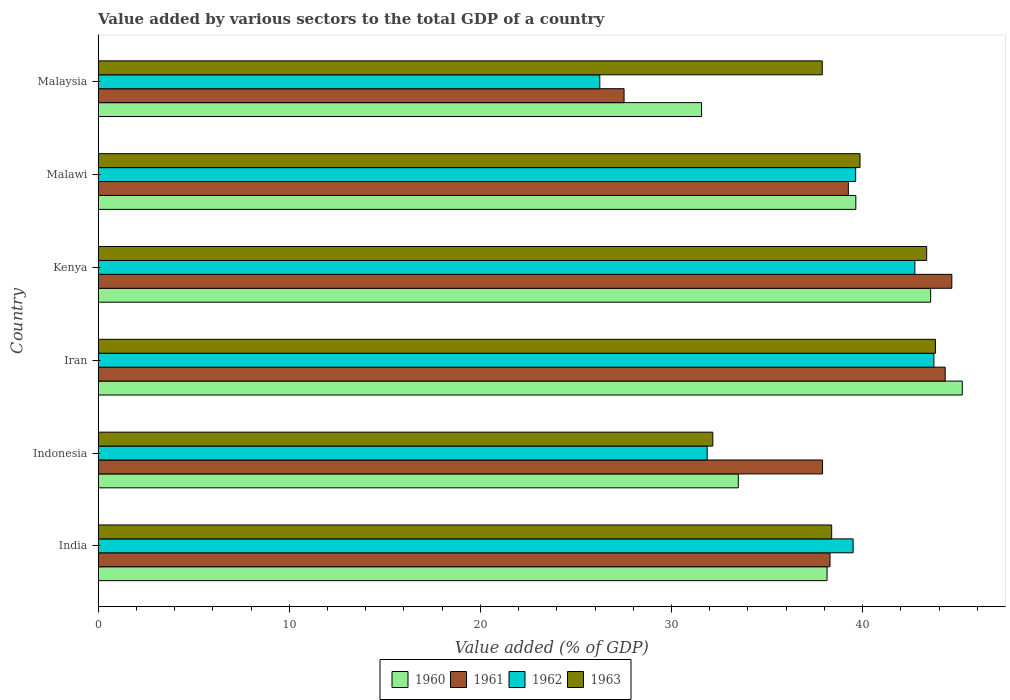How many different coloured bars are there?
Provide a succinct answer. 4. Are the number of bars per tick equal to the number of legend labels?
Your answer should be compact. Yes. Are the number of bars on each tick of the Y-axis equal?
Ensure brevity in your answer.  Yes. How many bars are there on the 4th tick from the bottom?
Offer a terse response. 4. What is the label of the 6th group of bars from the top?
Ensure brevity in your answer.  India. What is the value added by various sectors to the total GDP in 1961 in India?
Offer a very short reply. 38.29. Across all countries, what is the maximum value added by various sectors to the total GDP in 1963?
Provide a short and direct response. 43.81. Across all countries, what is the minimum value added by various sectors to the total GDP in 1963?
Ensure brevity in your answer.  32.16. In which country was the value added by various sectors to the total GDP in 1963 maximum?
Your answer should be compact. Iran. In which country was the value added by various sectors to the total GDP in 1962 minimum?
Offer a very short reply. Malaysia. What is the total value added by various sectors to the total GDP in 1962 in the graph?
Your response must be concise. 223.72. What is the difference between the value added by various sectors to the total GDP in 1962 in Indonesia and that in Kenya?
Ensure brevity in your answer.  -10.87. What is the difference between the value added by various sectors to the total GDP in 1961 in Iran and the value added by various sectors to the total GDP in 1960 in Indonesia?
Offer a very short reply. 10.82. What is the average value added by various sectors to the total GDP in 1963 per country?
Give a very brief answer. 39.24. What is the difference between the value added by various sectors to the total GDP in 1963 and value added by various sectors to the total GDP in 1962 in Indonesia?
Your answer should be very brief. 0.3. In how many countries, is the value added by various sectors to the total GDP in 1961 greater than 6 %?
Your answer should be very brief. 6. What is the ratio of the value added by various sectors to the total GDP in 1961 in India to that in Iran?
Give a very brief answer. 0.86. Is the value added by various sectors to the total GDP in 1961 in India less than that in Indonesia?
Offer a terse response. No. Is the difference between the value added by various sectors to the total GDP in 1963 in Kenya and Malawi greater than the difference between the value added by various sectors to the total GDP in 1962 in Kenya and Malawi?
Your response must be concise. Yes. What is the difference between the highest and the second highest value added by various sectors to the total GDP in 1961?
Give a very brief answer. 0.35. What is the difference between the highest and the lowest value added by various sectors to the total GDP in 1963?
Provide a succinct answer. 11.65. In how many countries, is the value added by various sectors to the total GDP in 1963 greater than the average value added by various sectors to the total GDP in 1963 taken over all countries?
Ensure brevity in your answer.  3. What does the 3rd bar from the bottom in Malaysia represents?
Give a very brief answer. 1962. Is it the case that in every country, the sum of the value added by various sectors to the total GDP in 1961 and value added by various sectors to the total GDP in 1962 is greater than the value added by various sectors to the total GDP in 1960?
Make the answer very short. Yes. How many bars are there?
Offer a terse response. 24. Are all the bars in the graph horizontal?
Provide a succinct answer. Yes. How many countries are there in the graph?
Ensure brevity in your answer.  6. Are the values on the major ticks of X-axis written in scientific E-notation?
Give a very brief answer. No. Where does the legend appear in the graph?
Provide a succinct answer. Bottom center. How are the legend labels stacked?
Give a very brief answer. Horizontal. What is the title of the graph?
Offer a terse response. Value added by various sectors to the total GDP of a country. Does "2014" appear as one of the legend labels in the graph?
Offer a terse response. No. What is the label or title of the X-axis?
Your answer should be compact. Value added (% of GDP). What is the Value added (% of GDP) in 1960 in India?
Keep it short and to the point. 38.14. What is the Value added (% of GDP) in 1961 in India?
Ensure brevity in your answer.  38.29. What is the Value added (% of GDP) in 1962 in India?
Your response must be concise. 39.5. What is the Value added (% of GDP) in 1963 in India?
Your answer should be compact. 38.38. What is the Value added (% of GDP) in 1960 in Indonesia?
Provide a succinct answer. 33.5. What is the Value added (% of GDP) of 1961 in Indonesia?
Offer a terse response. 37.9. What is the Value added (% of GDP) of 1962 in Indonesia?
Ensure brevity in your answer.  31.87. What is the Value added (% of GDP) in 1963 in Indonesia?
Provide a succinct answer. 32.16. What is the Value added (% of GDP) in 1960 in Iran?
Your answer should be compact. 45.21. What is the Value added (% of GDP) in 1961 in Iran?
Provide a short and direct response. 44.32. What is the Value added (% of GDP) in 1962 in Iran?
Offer a very short reply. 43.73. What is the Value added (% of GDP) of 1963 in Iran?
Offer a very short reply. 43.81. What is the Value added (% of GDP) in 1960 in Kenya?
Keep it short and to the point. 43.56. What is the Value added (% of GDP) of 1961 in Kenya?
Keep it short and to the point. 44.67. What is the Value added (% of GDP) in 1962 in Kenya?
Your answer should be compact. 42.73. What is the Value added (% of GDP) of 1963 in Kenya?
Make the answer very short. 43.35. What is the Value added (% of GDP) in 1960 in Malawi?
Give a very brief answer. 39.64. What is the Value added (% of GDP) of 1961 in Malawi?
Keep it short and to the point. 39.25. What is the Value added (% of GDP) in 1962 in Malawi?
Your answer should be very brief. 39.64. What is the Value added (% of GDP) of 1963 in Malawi?
Offer a terse response. 39.86. What is the Value added (% of GDP) of 1960 in Malaysia?
Offer a terse response. 31.57. What is the Value added (% of GDP) of 1961 in Malaysia?
Keep it short and to the point. 27.52. What is the Value added (% of GDP) in 1962 in Malaysia?
Make the answer very short. 26.25. What is the Value added (% of GDP) of 1963 in Malaysia?
Keep it short and to the point. 37.89. Across all countries, what is the maximum Value added (% of GDP) of 1960?
Your answer should be very brief. 45.21. Across all countries, what is the maximum Value added (% of GDP) in 1961?
Your answer should be very brief. 44.67. Across all countries, what is the maximum Value added (% of GDP) in 1962?
Give a very brief answer. 43.73. Across all countries, what is the maximum Value added (% of GDP) in 1963?
Give a very brief answer. 43.81. Across all countries, what is the minimum Value added (% of GDP) of 1960?
Ensure brevity in your answer.  31.57. Across all countries, what is the minimum Value added (% of GDP) in 1961?
Keep it short and to the point. 27.52. Across all countries, what is the minimum Value added (% of GDP) in 1962?
Give a very brief answer. 26.25. Across all countries, what is the minimum Value added (% of GDP) in 1963?
Provide a succinct answer. 32.16. What is the total Value added (% of GDP) in 1960 in the graph?
Your answer should be very brief. 231.63. What is the total Value added (% of GDP) in 1961 in the graph?
Make the answer very short. 231.95. What is the total Value added (% of GDP) in 1962 in the graph?
Your answer should be very brief. 223.72. What is the total Value added (% of GDP) of 1963 in the graph?
Keep it short and to the point. 235.46. What is the difference between the Value added (% of GDP) of 1960 in India and that in Indonesia?
Your response must be concise. 4.64. What is the difference between the Value added (% of GDP) of 1961 in India and that in Indonesia?
Your answer should be compact. 0.39. What is the difference between the Value added (% of GDP) of 1962 in India and that in Indonesia?
Offer a terse response. 7.64. What is the difference between the Value added (% of GDP) in 1963 in India and that in Indonesia?
Your response must be concise. 6.22. What is the difference between the Value added (% of GDP) of 1960 in India and that in Iran?
Keep it short and to the point. -7.08. What is the difference between the Value added (% of GDP) of 1961 in India and that in Iran?
Keep it short and to the point. -6.03. What is the difference between the Value added (% of GDP) of 1962 in India and that in Iran?
Your answer should be compact. -4.23. What is the difference between the Value added (% of GDP) of 1963 in India and that in Iran?
Ensure brevity in your answer.  -5.43. What is the difference between the Value added (% of GDP) in 1960 in India and that in Kenya?
Ensure brevity in your answer.  -5.42. What is the difference between the Value added (% of GDP) in 1961 in India and that in Kenya?
Offer a very short reply. -6.37. What is the difference between the Value added (% of GDP) of 1962 in India and that in Kenya?
Your answer should be compact. -3.23. What is the difference between the Value added (% of GDP) of 1963 in India and that in Kenya?
Provide a succinct answer. -4.97. What is the difference between the Value added (% of GDP) in 1960 in India and that in Malawi?
Provide a short and direct response. -1.51. What is the difference between the Value added (% of GDP) of 1961 in India and that in Malawi?
Give a very brief answer. -0.96. What is the difference between the Value added (% of GDP) of 1962 in India and that in Malawi?
Offer a very short reply. -0.13. What is the difference between the Value added (% of GDP) of 1963 in India and that in Malawi?
Your answer should be compact. -1.48. What is the difference between the Value added (% of GDP) in 1960 in India and that in Malaysia?
Ensure brevity in your answer.  6.57. What is the difference between the Value added (% of GDP) of 1961 in India and that in Malaysia?
Your response must be concise. 10.77. What is the difference between the Value added (% of GDP) of 1962 in India and that in Malaysia?
Ensure brevity in your answer.  13.25. What is the difference between the Value added (% of GDP) of 1963 in India and that in Malaysia?
Ensure brevity in your answer.  0.49. What is the difference between the Value added (% of GDP) of 1960 in Indonesia and that in Iran?
Your response must be concise. -11.72. What is the difference between the Value added (% of GDP) in 1961 in Indonesia and that in Iran?
Your answer should be compact. -6.42. What is the difference between the Value added (% of GDP) in 1962 in Indonesia and that in Iran?
Your answer should be very brief. -11.86. What is the difference between the Value added (% of GDP) of 1963 in Indonesia and that in Iran?
Your response must be concise. -11.65. What is the difference between the Value added (% of GDP) of 1960 in Indonesia and that in Kenya?
Ensure brevity in your answer.  -10.06. What is the difference between the Value added (% of GDP) of 1961 in Indonesia and that in Kenya?
Ensure brevity in your answer.  -6.76. What is the difference between the Value added (% of GDP) of 1962 in Indonesia and that in Kenya?
Make the answer very short. -10.87. What is the difference between the Value added (% of GDP) in 1963 in Indonesia and that in Kenya?
Ensure brevity in your answer.  -11.19. What is the difference between the Value added (% of GDP) in 1960 in Indonesia and that in Malawi?
Provide a succinct answer. -6.15. What is the difference between the Value added (% of GDP) of 1961 in Indonesia and that in Malawi?
Ensure brevity in your answer.  -1.35. What is the difference between the Value added (% of GDP) of 1962 in Indonesia and that in Malawi?
Your answer should be compact. -7.77. What is the difference between the Value added (% of GDP) of 1963 in Indonesia and that in Malawi?
Offer a terse response. -7.7. What is the difference between the Value added (% of GDP) in 1960 in Indonesia and that in Malaysia?
Provide a short and direct response. 1.92. What is the difference between the Value added (% of GDP) in 1961 in Indonesia and that in Malaysia?
Offer a very short reply. 10.39. What is the difference between the Value added (% of GDP) of 1962 in Indonesia and that in Malaysia?
Provide a short and direct response. 5.62. What is the difference between the Value added (% of GDP) of 1963 in Indonesia and that in Malaysia?
Keep it short and to the point. -5.73. What is the difference between the Value added (% of GDP) of 1960 in Iran and that in Kenya?
Your answer should be very brief. 1.65. What is the difference between the Value added (% of GDP) in 1961 in Iran and that in Kenya?
Ensure brevity in your answer.  -0.35. What is the difference between the Value added (% of GDP) of 1963 in Iran and that in Kenya?
Offer a very short reply. 0.46. What is the difference between the Value added (% of GDP) in 1960 in Iran and that in Malawi?
Your answer should be very brief. 5.57. What is the difference between the Value added (% of GDP) of 1961 in Iran and that in Malawi?
Keep it short and to the point. 5.07. What is the difference between the Value added (% of GDP) of 1962 in Iran and that in Malawi?
Make the answer very short. 4.09. What is the difference between the Value added (% of GDP) in 1963 in Iran and that in Malawi?
Your answer should be compact. 3.95. What is the difference between the Value added (% of GDP) in 1960 in Iran and that in Malaysia?
Provide a succinct answer. 13.64. What is the difference between the Value added (% of GDP) in 1961 in Iran and that in Malaysia?
Keep it short and to the point. 16.8. What is the difference between the Value added (% of GDP) in 1962 in Iran and that in Malaysia?
Offer a very short reply. 17.48. What is the difference between the Value added (% of GDP) in 1963 in Iran and that in Malaysia?
Offer a very short reply. 5.92. What is the difference between the Value added (% of GDP) of 1960 in Kenya and that in Malawi?
Keep it short and to the point. 3.92. What is the difference between the Value added (% of GDP) in 1961 in Kenya and that in Malawi?
Make the answer very short. 5.41. What is the difference between the Value added (% of GDP) of 1962 in Kenya and that in Malawi?
Make the answer very short. 3.1. What is the difference between the Value added (% of GDP) in 1963 in Kenya and that in Malawi?
Your answer should be compact. 3.49. What is the difference between the Value added (% of GDP) in 1960 in Kenya and that in Malaysia?
Your response must be concise. 11.99. What is the difference between the Value added (% of GDP) in 1961 in Kenya and that in Malaysia?
Offer a very short reply. 17.15. What is the difference between the Value added (% of GDP) in 1962 in Kenya and that in Malaysia?
Your answer should be compact. 16.48. What is the difference between the Value added (% of GDP) of 1963 in Kenya and that in Malaysia?
Ensure brevity in your answer.  5.46. What is the difference between the Value added (% of GDP) of 1960 in Malawi and that in Malaysia?
Make the answer very short. 8.07. What is the difference between the Value added (% of GDP) of 1961 in Malawi and that in Malaysia?
Your answer should be very brief. 11.73. What is the difference between the Value added (% of GDP) of 1962 in Malawi and that in Malaysia?
Ensure brevity in your answer.  13.39. What is the difference between the Value added (% of GDP) of 1963 in Malawi and that in Malaysia?
Offer a very short reply. 1.98. What is the difference between the Value added (% of GDP) in 1960 in India and the Value added (% of GDP) in 1961 in Indonesia?
Your answer should be compact. 0.24. What is the difference between the Value added (% of GDP) of 1960 in India and the Value added (% of GDP) of 1962 in Indonesia?
Ensure brevity in your answer.  6.27. What is the difference between the Value added (% of GDP) of 1960 in India and the Value added (% of GDP) of 1963 in Indonesia?
Offer a terse response. 5.98. What is the difference between the Value added (% of GDP) in 1961 in India and the Value added (% of GDP) in 1962 in Indonesia?
Provide a succinct answer. 6.43. What is the difference between the Value added (% of GDP) in 1961 in India and the Value added (% of GDP) in 1963 in Indonesia?
Ensure brevity in your answer.  6.13. What is the difference between the Value added (% of GDP) in 1962 in India and the Value added (% of GDP) in 1963 in Indonesia?
Offer a very short reply. 7.34. What is the difference between the Value added (% of GDP) in 1960 in India and the Value added (% of GDP) in 1961 in Iran?
Ensure brevity in your answer.  -6.18. What is the difference between the Value added (% of GDP) of 1960 in India and the Value added (% of GDP) of 1962 in Iran?
Provide a succinct answer. -5.59. What is the difference between the Value added (% of GDP) of 1960 in India and the Value added (% of GDP) of 1963 in Iran?
Offer a very short reply. -5.67. What is the difference between the Value added (% of GDP) in 1961 in India and the Value added (% of GDP) in 1962 in Iran?
Your response must be concise. -5.44. What is the difference between the Value added (% of GDP) in 1961 in India and the Value added (% of GDP) in 1963 in Iran?
Offer a terse response. -5.52. What is the difference between the Value added (% of GDP) in 1962 in India and the Value added (% of GDP) in 1963 in Iran?
Keep it short and to the point. -4.31. What is the difference between the Value added (% of GDP) in 1960 in India and the Value added (% of GDP) in 1961 in Kenya?
Your response must be concise. -6.53. What is the difference between the Value added (% of GDP) in 1960 in India and the Value added (% of GDP) in 1962 in Kenya?
Your answer should be very brief. -4.59. What is the difference between the Value added (% of GDP) of 1960 in India and the Value added (% of GDP) of 1963 in Kenya?
Your answer should be very brief. -5.21. What is the difference between the Value added (% of GDP) in 1961 in India and the Value added (% of GDP) in 1962 in Kenya?
Provide a short and direct response. -4.44. What is the difference between the Value added (% of GDP) of 1961 in India and the Value added (% of GDP) of 1963 in Kenya?
Provide a short and direct response. -5.06. What is the difference between the Value added (% of GDP) in 1962 in India and the Value added (% of GDP) in 1963 in Kenya?
Keep it short and to the point. -3.85. What is the difference between the Value added (% of GDP) of 1960 in India and the Value added (% of GDP) of 1961 in Malawi?
Provide a succinct answer. -1.11. What is the difference between the Value added (% of GDP) in 1960 in India and the Value added (% of GDP) in 1962 in Malawi?
Offer a terse response. -1.5. What is the difference between the Value added (% of GDP) in 1960 in India and the Value added (% of GDP) in 1963 in Malawi?
Your response must be concise. -1.72. What is the difference between the Value added (% of GDP) in 1961 in India and the Value added (% of GDP) in 1962 in Malawi?
Make the answer very short. -1.34. What is the difference between the Value added (% of GDP) in 1961 in India and the Value added (% of GDP) in 1963 in Malawi?
Your answer should be compact. -1.57. What is the difference between the Value added (% of GDP) of 1962 in India and the Value added (% of GDP) of 1963 in Malawi?
Offer a very short reply. -0.36. What is the difference between the Value added (% of GDP) of 1960 in India and the Value added (% of GDP) of 1961 in Malaysia?
Offer a terse response. 10.62. What is the difference between the Value added (% of GDP) of 1960 in India and the Value added (% of GDP) of 1962 in Malaysia?
Provide a succinct answer. 11.89. What is the difference between the Value added (% of GDP) in 1960 in India and the Value added (% of GDP) in 1963 in Malaysia?
Provide a short and direct response. 0.25. What is the difference between the Value added (% of GDP) in 1961 in India and the Value added (% of GDP) in 1962 in Malaysia?
Offer a terse response. 12.04. What is the difference between the Value added (% of GDP) in 1961 in India and the Value added (% of GDP) in 1963 in Malaysia?
Your answer should be very brief. 0.41. What is the difference between the Value added (% of GDP) of 1962 in India and the Value added (% of GDP) of 1963 in Malaysia?
Provide a short and direct response. 1.62. What is the difference between the Value added (% of GDP) of 1960 in Indonesia and the Value added (% of GDP) of 1961 in Iran?
Offer a very short reply. -10.82. What is the difference between the Value added (% of GDP) of 1960 in Indonesia and the Value added (% of GDP) of 1962 in Iran?
Offer a very short reply. -10.24. What is the difference between the Value added (% of GDP) in 1960 in Indonesia and the Value added (% of GDP) in 1963 in Iran?
Your answer should be very brief. -10.32. What is the difference between the Value added (% of GDP) of 1961 in Indonesia and the Value added (% of GDP) of 1962 in Iran?
Provide a succinct answer. -5.83. What is the difference between the Value added (% of GDP) of 1961 in Indonesia and the Value added (% of GDP) of 1963 in Iran?
Provide a succinct answer. -5.91. What is the difference between the Value added (% of GDP) of 1962 in Indonesia and the Value added (% of GDP) of 1963 in Iran?
Ensure brevity in your answer.  -11.94. What is the difference between the Value added (% of GDP) in 1960 in Indonesia and the Value added (% of GDP) in 1961 in Kenya?
Provide a short and direct response. -11.17. What is the difference between the Value added (% of GDP) of 1960 in Indonesia and the Value added (% of GDP) of 1962 in Kenya?
Keep it short and to the point. -9.24. What is the difference between the Value added (% of GDP) in 1960 in Indonesia and the Value added (% of GDP) in 1963 in Kenya?
Your response must be concise. -9.86. What is the difference between the Value added (% of GDP) in 1961 in Indonesia and the Value added (% of GDP) in 1962 in Kenya?
Offer a very short reply. -4.83. What is the difference between the Value added (% of GDP) of 1961 in Indonesia and the Value added (% of GDP) of 1963 in Kenya?
Offer a very short reply. -5.45. What is the difference between the Value added (% of GDP) in 1962 in Indonesia and the Value added (% of GDP) in 1963 in Kenya?
Give a very brief answer. -11.48. What is the difference between the Value added (% of GDP) in 1960 in Indonesia and the Value added (% of GDP) in 1961 in Malawi?
Keep it short and to the point. -5.76. What is the difference between the Value added (% of GDP) in 1960 in Indonesia and the Value added (% of GDP) in 1962 in Malawi?
Offer a very short reply. -6.14. What is the difference between the Value added (% of GDP) of 1960 in Indonesia and the Value added (% of GDP) of 1963 in Malawi?
Your answer should be compact. -6.37. What is the difference between the Value added (% of GDP) of 1961 in Indonesia and the Value added (% of GDP) of 1962 in Malawi?
Offer a very short reply. -1.73. What is the difference between the Value added (% of GDP) of 1961 in Indonesia and the Value added (% of GDP) of 1963 in Malawi?
Provide a succinct answer. -1.96. What is the difference between the Value added (% of GDP) in 1962 in Indonesia and the Value added (% of GDP) in 1963 in Malawi?
Your answer should be very brief. -8. What is the difference between the Value added (% of GDP) of 1960 in Indonesia and the Value added (% of GDP) of 1961 in Malaysia?
Provide a succinct answer. 5.98. What is the difference between the Value added (% of GDP) in 1960 in Indonesia and the Value added (% of GDP) in 1962 in Malaysia?
Offer a very short reply. 7.25. What is the difference between the Value added (% of GDP) in 1960 in Indonesia and the Value added (% of GDP) in 1963 in Malaysia?
Make the answer very short. -4.39. What is the difference between the Value added (% of GDP) in 1961 in Indonesia and the Value added (% of GDP) in 1962 in Malaysia?
Offer a very short reply. 11.65. What is the difference between the Value added (% of GDP) of 1961 in Indonesia and the Value added (% of GDP) of 1963 in Malaysia?
Your response must be concise. 0.02. What is the difference between the Value added (% of GDP) in 1962 in Indonesia and the Value added (% of GDP) in 1963 in Malaysia?
Give a very brief answer. -6.02. What is the difference between the Value added (% of GDP) of 1960 in Iran and the Value added (% of GDP) of 1961 in Kenya?
Provide a short and direct response. 0.55. What is the difference between the Value added (% of GDP) of 1960 in Iran and the Value added (% of GDP) of 1962 in Kenya?
Your response must be concise. 2.48. What is the difference between the Value added (% of GDP) in 1960 in Iran and the Value added (% of GDP) in 1963 in Kenya?
Provide a short and direct response. 1.86. What is the difference between the Value added (% of GDP) in 1961 in Iran and the Value added (% of GDP) in 1962 in Kenya?
Your answer should be very brief. 1.59. What is the difference between the Value added (% of GDP) in 1961 in Iran and the Value added (% of GDP) in 1963 in Kenya?
Make the answer very short. 0.97. What is the difference between the Value added (% of GDP) in 1962 in Iran and the Value added (% of GDP) in 1963 in Kenya?
Your answer should be compact. 0.38. What is the difference between the Value added (% of GDP) of 1960 in Iran and the Value added (% of GDP) of 1961 in Malawi?
Offer a terse response. 5.96. What is the difference between the Value added (% of GDP) of 1960 in Iran and the Value added (% of GDP) of 1962 in Malawi?
Provide a short and direct response. 5.58. What is the difference between the Value added (% of GDP) of 1960 in Iran and the Value added (% of GDP) of 1963 in Malawi?
Your answer should be very brief. 5.35. What is the difference between the Value added (% of GDP) of 1961 in Iran and the Value added (% of GDP) of 1962 in Malawi?
Provide a short and direct response. 4.68. What is the difference between the Value added (% of GDP) in 1961 in Iran and the Value added (% of GDP) in 1963 in Malawi?
Ensure brevity in your answer.  4.46. What is the difference between the Value added (% of GDP) of 1962 in Iran and the Value added (% of GDP) of 1963 in Malawi?
Ensure brevity in your answer.  3.87. What is the difference between the Value added (% of GDP) of 1960 in Iran and the Value added (% of GDP) of 1961 in Malaysia?
Give a very brief answer. 17.7. What is the difference between the Value added (% of GDP) of 1960 in Iran and the Value added (% of GDP) of 1962 in Malaysia?
Provide a succinct answer. 18.96. What is the difference between the Value added (% of GDP) in 1960 in Iran and the Value added (% of GDP) in 1963 in Malaysia?
Provide a succinct answer. 7.33. What is the difference between the Value added (% of GDP) in 1961 in Iran and the Value added (% of GDP) in 1962 in Malaysia?
Give a very brief answer. 18.07. What is the difference between the Value added (% of GDP) in 1961 in Iran and the Value added (% of GDP) in 1963 in Malaysia?
Make the answer very short. 6.43. What is the difference between the Value added (% of GDP) in 1962 in Iran and the Value added (% of GDP) in 1963 in Malaysia?
Make the answer very short. 5.84. What is the difference between the Value added (% of GDP) in 1960 in Kenya and the Value added (% of GDP) in 1961 in Malawi?
Offer a terse response. 4.31. What is the difference between the Value added (% of GDP) of 1960 in Kenya and the Value added (% of GDP) of 1962 in Malawi?
Ensure brevity in your answer.  3.92. What is the difference between the Value added (% of GDP) in 1960 in Kenya and the Value added (% of GDP) in 1963 in Malawi?
Ensure brevity in your answer.  3.7. What is the difference between the Value added (% of GDP) of 1961 in Kenya and the Value added (% of GDP) of 1962 in Malawi?
Your answer should be very brief. 5.03. What is the difference between the Value added (% of GDP) of 1961 in Kenya and the Value added (% of GDP) of 1963 in Malawi?
Offer a very short reply. 4.8. What is the difference between the Value added (% of GDP) of 1962 in Kenya and the Value added (% of GDP) of 1963 in Malawi?
Keep it short and to the point. 2.87. What is the difference between the Value added (% of GDP) in 1960 in Kenya and the Value added (% of GDP) in 1961 in Malaysia?
Offer a very short reply. 16.04. What is the difference between the Value added (% of GDP) of 1960 in Kenya and the Value added (% of GDP) of 1962 in Malaysia?
Provide a succinct answer. 17.31. What is the difference between the Value added (% of GDP) of 1960 in Kenya and the Value added (% of GDP) of 1963 in Malaysia?
Your answer should be compact. 5.67. What is the difference between the Value added (% of GDP) in 1961 in Kenya and the Value added (% of GDP) in 1962 in Malaysia?
Ensure brevity in your answer.  18.42. What is the difference between the Value added (% of GDP) of 1961 in Kenya and the Value added (% of GDP) of 1963 in Malaysia?
Keep it short and to the point. 6.78. What is the difference between the Value added (% of GDP) in 1962 in Kenya and the Value added (% of GDP) in 1963 in Malaysia?
Ensure brevity in your answer.  4.84. What is the difference between the Value added (% of GDP) of 1960 in Malawi and the Value added (% of GDP) of 1961 in Malaysia?
Offer a very short reply. 12.13. What is the difference between the Value added (% of GDP) of 1960 in Malawi and the Value added (% of GDP) of 1962 in Malaysia?
Provide a succinct answer. 13.39. What is the difference between the Value added (% of GDP) of 1960 in Malawi and the Value added (% of GDP) of 1963 in Malaysia?
Offer a terse response. 1.76. What is the difference between the Value added (% of GDP) in 1961 in Malawi and the Value added (% of GDP) in 1962 in Malaysia?
Offer a terse response. 13. What is the difference between the Value added (% of GDP) in 1961 in Malawi and the Value added (% of GDP) in 1963 in Malaysia?
Ensure brevity in your answer.  1.37. What is the difference between the Value added (% of GDP) in 1962 in Malawi and the Value added (% of GDP) in 1963 in Malaysia?
Ensure brevity in your answer.  1.75. What is the average Value added (% of GDP) in 1960 per country?
Make the answer very short. 38.6. What is the average Value added (% of GDP) in 1961 per country?
Give a very brief answer. 38.66. What is the average Value added (% of GDP) in 1962 per country?
Make the answer very short. 37.29. What is the average Value added (% of GDP) in 1963 per country?
Make the answer very short. 39.24. What is the difference between the Value added (% of GDP) in 1960 and Value added (% of GDP) in 1961 in India?
Provide a short and direct response. -0.15. What is the difference between the Value added (% of GDP) in 1960 and Value added (% of GDP) in 1962 in India?
Offer a terse response. -1.36. What is the difference between the Value added (% of GDP) of 1960 and Value added (% of GDP) of 1963 in India?
Make the answer very short. -0.24. What is the difference between the Value added (% of GDP) of 1961 and Value added (% of GDP) of 1962 in India?
Make the answer very short. -1.21. What is the difference between the Value added (% of GDP) in 1961 and Value added (% of GDP) in 1963 in India?
Offer a very short reply. -0.09. What is the difference between the Value added (% of GDP) of 1962 and Value added (% of GDP) of 1963 in India?
Provide a short and direct response. 1.12. What is the difference between the Value added (% of GDP) in 1960 and Value added (% of GDP) in 1961 in Indonesia?
Your response must be concise. -4.41. What is the difference between the Value added (% of GDP) of 1960 and Value added (% of GDP) of 1962 in Indonesia?
Give a very brief answer. 1.63. What is the difference between the Value added (% of GDP) in 1960 and Value added (% of GDP) in 1963 in Indonesia?
Make the answer very short. 1.33. What is the difference between the Value added (% of GDP) in 1961 and Value added (% of GDP) in 1962 in Indonesia?
Offer a very short reply. 6.04. What is the difference between the Value added (% of GDP) in 1961 and Value added (% of GDP) in 1963 in Indonesia?
Give a very brief answer. 5.74. What is the difference between the Value added (% of GDP) in 1962 and Value added (% of GDP) in 1963 in Indonesia?
Keep it short and to the point. -0.3. What is the difference between the Value added (% of GDP) of 1960 and Value added (% of GDP) of 1961 in Iran?
Your answer should be compact. 0.89. What is the difference between the Value added (% of GDP) in 1960 and Value added (% of GDP) in 1962 in Iran?
Give a very brief answer. 1.48. What is the difference between the Value added (% of GDP) in 1960 and Value added (% of GDP) in 1963 in Iran?
Your answer should be compact. 1.4. What is the difference between the Value added (% of GDP) in 1961 and Value added (% of GDP) in 1962 in Iran?
Offer a terse response. 0.59. What is the difference between the Value added (% of GDP) of 1961 and Value added (% of GDP) of 1963 in Iran?
Make the answer very short. 0.51. What is the difference between the Value added (% of GDP) in 1962 and Value added (% of GDP) in 1963 in Iran?
Offer a very short reply. -0.08. What is the difference between the Value added (% of GDP) of 1960 and Value added (% of GDP) of 1961 in Kenya?
Make the answer very short. -1.11. What is the difference between the Value added (% of GDP) of 1960 and Value added (% of GDP) of 1962 in Kenya?
Your answer should be very brief. 0.83. What is the difference between the Value added (% of GDP) in 1960 and Value added (% of GDP) in 1963 in Kenya?
Your response must be concise. 0.21. What is the difference between the Value added (% of GDP) of 1961 and Value added (% of GDP) of 1962 in Kenya?
Offer a very short reply. 1.94. What is the difference between the Value added (% of GDP) of 1961 and Value added (% of GDP) of 1963 in Kenya?
Provide a succinct answer. 1.32. What is the difference between the Value added (% of GDP) of 1962 and Value added (% of GDP) of 1963 in Kenya?
Ensure brevity in your answer.  -0.62. What is the difference between the Value added (% of GDP) of 1960 and Value added (% of GDP) of 1961 in Malawi?
Ensure brevity in your answer.  0.39. What is the difference between the Value added (% of GDP) in 1960 and Value added (% of GDP) in 1962 in Malawi?
Make the answer very short. 0.01. What is the difference between the Value added (% of GDP) of 1960 and Value added (% of GDP) of 1963 in Malawi?
Your answer should be very brief. -0.22. What is the difference between the Value added (% of GDP) in 1961 and Value added (% of GDP) in 1962 in Malawi?
Make the answer very short. -0.38. What is the difference between the Value added (% of GDP) of 1961 and Value added (% of GDP) of 1963 in Malawi?
Provide a short and direct response. -0.61. What is the difference between the Value added (% of GDP) of 1962 and Value added (% of GDP) of 1963 in Malawi?
Give a very brief answer. -0.23. What is the difference between the Value added (% of GDP) in 1960 and Value added (% of GDP) in 1961 in Malaysia?
Your answer should be very brief. 4.05. What is the difference between the Value added (% of GDP) of 1960 and Value added (% of GDP) of 1962 in Malaysia?
Your answer should be very brief. 5.32. What is the difference between the Value added (% of GDP) in 1960 and Value added (% of GDP) in 1963 in Malaysia?
Ensure brevity in your answer.  -6.31. What is the difference between the Value added (% of GDP) of 1961 and Value added (% of GDP) of 1962 in Malaysia?
Offer a very short reply. 1.27. What is the difference between the Value added (% of GDP) of 1961 and Value added (% of GDP) of 1963 in Malaysia?
Make the answer very short. -10.37. What is the difference between the Value added (% of GDP) in 1962 and Value added (% of GDP) in 1963 in Malaysia?
Provide a short and direct response. -11.64. What is the ratio of the Value added (% of GDP) of 1960 in India to that in Indonesia?
Ensure brevity in your answer.  1.14. What is the ratio of the Value added (% of GDP) of 1961 in India to that in Indonesia?
Provide a succinct answer. 1.01. What is the ratio of the Value added (% of GDP) in 1962 in India to that in Indonesia?
Your answer should be compact. 1.24. What is the ratio of the Value added (% of GDP) in 1963 in India to that in Indonesia?
Provide a short and direct response. 1.19. What is the ratio of the Value added (% of GDP) in 1960 in India to that in Iran?
Provide a succinct answer. 0.84. What is the ratio of the Value added (% of GDP) of 1961 in India to that in Iran?
Provide a succinct answer. 0.86. What is the ratio of the Value added (% of GDP) of 1962 in India to that in Iran?
Provide a short and direct response. 0.9. What is the ratio of the Value added (% of GDP) in 1963 in India to that in Iran?
Provide a succinct answer. 0.88. What is the ratio of the Value added (% of GDP) in 1960 in India to that in Kenya?
Your answer should be compact. 0.88. What is the ratio of the Value added (% of GDP) in 1961 in India to that in Kenya?
Your answer should be very brief. 0.86. What is the ratio of the Value added (% of GDP) in 1962 in India to that in Kenya?
Provide a succinct answer. 0.92. What is the ratio of the Value added (% of GDP) in 1963 in India to that in Kenya?
Your answer should be compact. 0.89. What is the ratio of the Value added (% of GDP) in 1960 in India to that in Malawi?
Give a very brief answer. 0.96. What is the ratio of the Value added (% of GDP) in 1961 in India to that in Malawi?
Your response must be concise. 0.98. What is the ratio of the Value added (% of GDP) of 1962 in India to that in Malawi?
Provide a succinct answer. 1. What is the ratio of the Value added (% of GDP) of 1963 in India to that in Malawi?
Your response must be concise. 0.96. What is the ratio of the Value added (% of GDP) in 1960 in India to that in Malaysia?
Keep it short and to the point. 1.21. What is the ratio of the Value added (% of GDP) of 1961 in India to that in Malaysia?
Keep it short and to the point. 1.39. What is the ratio of the Value added (% of GDP) of 1962 in India to that in Malaysia?
Your answer should be compact. 1.5. What is the ratio of the Value added (% of GDP) of 1963 in India to that in Malaysia?
Ensure brevity in your answer.  1.01. What is the ratio of the Value added (% of GDP) of 1960 in Indonesia to that in Iran?
Provide a short and direct response. 0.74. What is the ratio of the Value added (% of GDP) in 1961 in Indonesia to that in Iran?
Give a very brief answer. 0.86. What is the ratio of the Value added (% of GDP) of 1962 in Indonesia to that in Iran?
Offer a very short reply. 0.73. What is the ratio of the Value added (% of GDP) of 1963 in Indonesia to that in Iran?
Provide a succinct answer. 0.73. What is the ratio of the Value added (% of GDP) in 1960 in Indonesia to that in Kenya?
Keep it short and to the point. 0.77. What is the ratio of the Value added (% of GDP) of 1961 in Indonesia to that in Kenya?
Give a very brief answer. 0.85. What is the ratio of the Value added (% of GDP) in 1962 in Indonesia to that in Kenya?
Provide a short and direct response. 0.75. What is the ratio of the Value added (% of GDP) of 1963 in Indonesia to that in Kenya?
Your response must be concise. 0.74. What is the ratio of the Value added (% of GDP) in 1960 in Indonesia to that in Malawi?
Offer a terse response. 0.84. What is the ratio of the Value added (% of GDP) in 1961 in Indonesia to that in Malawi?
Your answer should be compact. 0.97. What is the ratio of the Value added (% of GDP) of 1962 in Indonesia to that in Malawi?
Keep it short and to the point. 0.8. What is the ratio of the Value added (% of GDP) in 1963 in Indonesia to that in Malawi?
Provide a succinct answer. 0.81. What is the ratio of the Value added (% of GDP) of 1960 in Indonesia to that in Malaysia?
Ensure brevity in your answer.  1.06. What is the ratio of the Value added (% of GDP) in 1961 in Indonesia to that in Malaysia?
Make the answer very short. 1.38. What is the ratio of the Value added (% of GDP) in 1962 in Indonesia to that in Malaysia?
Keep it short and to the point. 1.21. What is the ratio of the Value added (% of GDP) in 1963 in Indonesia to that in Malaysia?
Ensure brevity in your answer.  0.85. What is the ratio of the Value added (% of GDP) of 1960 in Iran to that in Kenya?
Offer a terse response. 1.04. What is the ratio of the Value added (% of GDP) in 1962 in Iran to that in Kenya?
Provide a succinct answer. 1.02. What is the ratio of the Value added (% of GDP) of 1963 in Iran to that in Kenya?
Your answer should be very brief. 1.01. What is the ratio of the Value added (% of GDP) of 1960 in Iran to that in Malawi?
Your response must be concise. 1.14. What is the ratio of the Value added (% of GDP) in 1961 in Iran to that in Malawi?
Give a very brief answer. 1.13. What is the ratio of the Value added (% of GDP) in 1962 in Iran to that in Malawi?
Your response must be concise. 1.1. What is the ratio of the Value added (% of GDP) of 1963 in Iran to that in Malawi?
Your response must be concise. 1.1. What is the ratio of the Value added (% of GDP) in 1960 in Iran to that in Malaysia?
Ensure brevity in your answer.  1.43. What is the ratio of the Value added (% of GDP) of 1961 in Iran to that in Malaysia?
Make the answer very short. 1.61. What is the ratio of the Value added (% of GDP) in 1962 in Iran to that in Malaysia?
Your answer should be compact. 1.67. What is the ratio of the Value added (% of GDP) in 1963 in Iran to that in Malaysia?
Make the answer very short. 1.16. What is the ratio of the Value added (% of GDP) of 1960 in Kenya to that in Malawi?
Provide a short and direct response. 1.1. What is the ratio of the Value added (% of GDP) in 1961 in Kenya to that in Malawi?
Offer a terse response. 1.14. What is the ratio of the Value added (% of GDP) in 1962 in Kenya to that in Malawi?
Provide a succinct answer. 1.08. What is the ratio of the Value added (% of GDP) of 1963 in Kenya to that in Malawi?
Provide a short and direct response. 1.09. What is the ratio of the Value added (% of GDP) of 1960 in Kenya to that in Malaysia?
Ensure brevity in your answer.  1.38. What is the ratio of the Value added (% of GDP) of 1961 in Kenya to that in Malaysia?
Your response must be concise. 1.62. What is the ratio of the Value added (% of GDP) of 1962 in Kenya to that in Malaysia?
Offer a very short reply. 1.63. What is the ratio of the Value added (% of GDP) in 1963 in Kenya to that in Malaysia?
Your answer should be compact. 1.14. What is the ratio of the Value added (% of GDP) of 1960 in Malawi to that in Malaysia?
Keep it short and to the point. 1.26. What is the ratio of the Value added (% of GDP) in 1961 in Malawi to that in Malaysia?
Your answer should be compact. 1.43. What is the ratio of the Value added (% of GDP) of 1962 in Malawi to that in Malaysia?
Offer a very short reply. 1.51. What is the ratio of the Value added (% of GDP) of 1963 in Malawi to that in Malaysia?
Your answer should be very brief. 1.05. What is the difference between the highest and the second highest Value added (% of GDP) in 1960?
Provide a short and direct response. 1.65. What is the difference between the highest and the second highest Value added (% of GDP) in 1961?
Offer a very short reply. 0.35. What is the difference between the highest and the second highest Value added (% of GDP) of 1963?
Offer a very short reply. 0.46. What is the difference between the highest and the lowest Value added (% of GDP) in 1960?
Give a very brief answer. 13.64. What is the difference between the highest and the lowest Value added (% of GDP) in 1961?
Offer a very short reply. 17.15. What is the difference between the highest and the lowest Value added (% of GDP) in 1962?
Keep it short and to the point. 17.48. What is the difference between the highest and the lowest Value added (% of GDP) of 1963?
Your response must be concise. 11.65. 